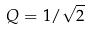<formula> <loc_0><loc_0><loc_500><loc_500>Q = 1 / \sqrt { 2 }</formula> 